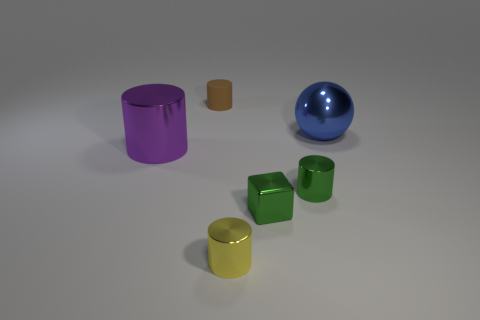There is a thing that is behind the large cylinder and left of the blue sphere; what color is it?
Give a very brief answer. Brown. Are there more blue things that are in front of the tiny brown matte cylinder than large green matte cubes?
Your answer should be compact. Yes. Is there a large purple cylinder?
Offer a terse response. Yes. What number of small objects are green cylinders or blue spheres?
Provide a short and direct response. 1. Is there anything else that has the same color as the block?
Your response must be concise. Yes. The small yellow thing that is made of the same material as the big cylinder is what shape?
Provide a short and direct response. Cylinder. What is the size of the cylinder that is behind the big shiny cylinder?
Make the answer very short. Small. What is the shape of the blue object?
Your answer should be compact. Sphere. Does the blue shiny ball on the right side of the purple metal thing have the same size as the thing that is behind the large blue metallic ball?
Ensure brevity in your answer.  No. There is a cylinder that is left of the small cylinder behind the thing that is on the left side of the small brown matte cylinder; how big is it?
Your answer should be very brief. Large. 